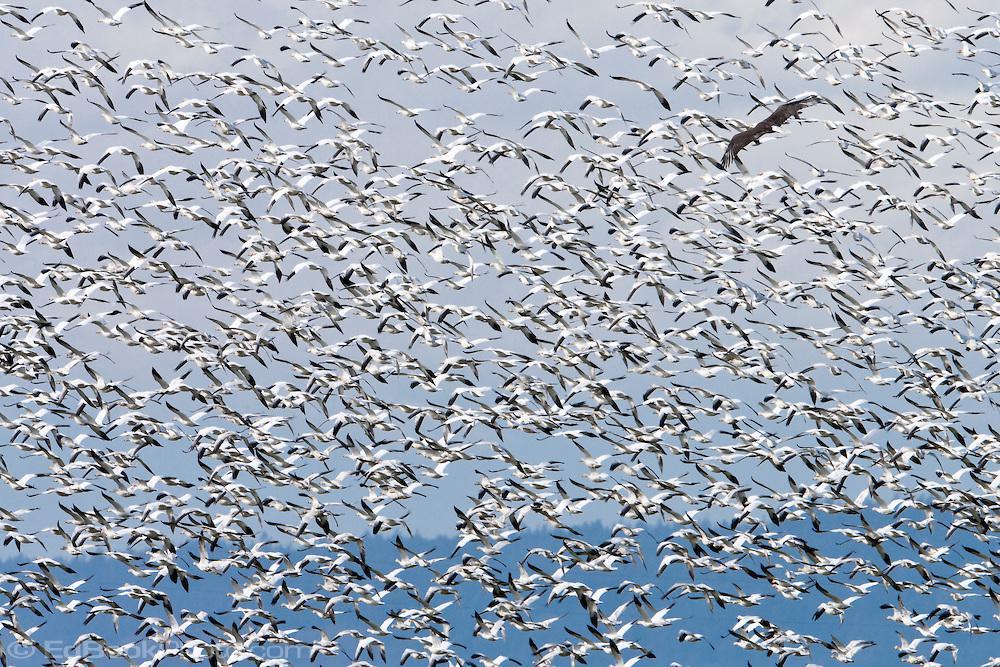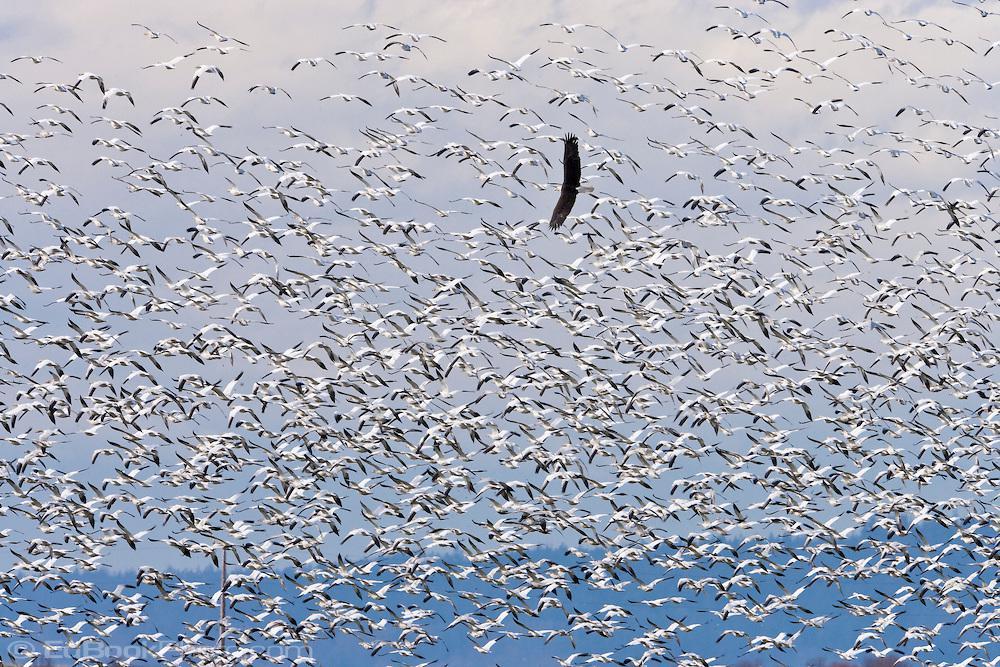The first image is the image on the left, the second image is the image on the right. Evaluate the accuracy of this statement regarding the images: "In at least one of the images, you can see the ground at the bottom of the frame.". Is it true? Answer yes or no. No. The first image is the image on the left, the second image is the image on the right. Assess this claim about the two images: "A horizon is visible behind a mass of flying birds in at least one image, and no image has any one bird that stands out as different from the rest.". Correct or not? Answer yes or no. No. 